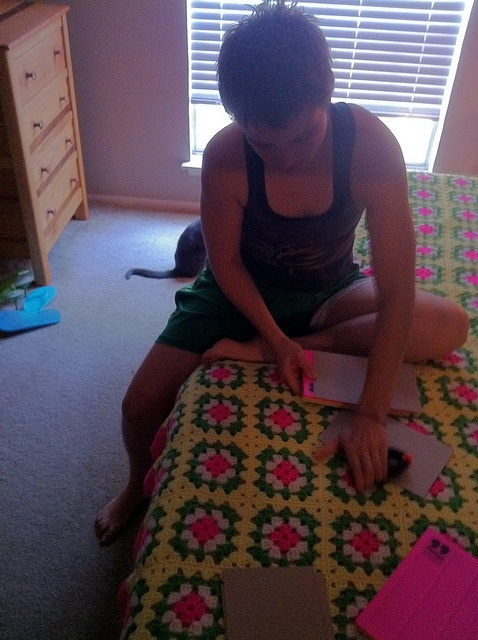Describe the objects in this image and their specific colors. I can see bed in maroon, black, and gray tones, people in maroon, black, navy, and purple tones, book in maroon, purple, and black tones, and cat in maroon, black, navy, gray, and purple tones in this image. 